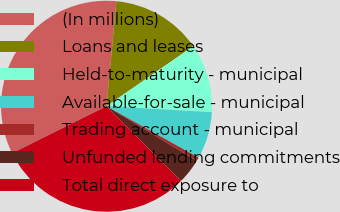<chart> <loc_0><loc_0><loc_500><loc_500><pie_chart><fcel>(In millions)<fcel>Loans and leases<fcel>Held-to-maturity - municipal<fcel>Available-for-sale - municipal<fcel>Trading account - municipal<fcel>Unfunded lending commitments<fcel>Total direct exposure to<nl><fcel>33.84%<fcel>13.87%<fcel>10.54%<fcel>7.21%<fcel>0.55%<fcel>3.88%<fcel>30.11%<nl></chart> 